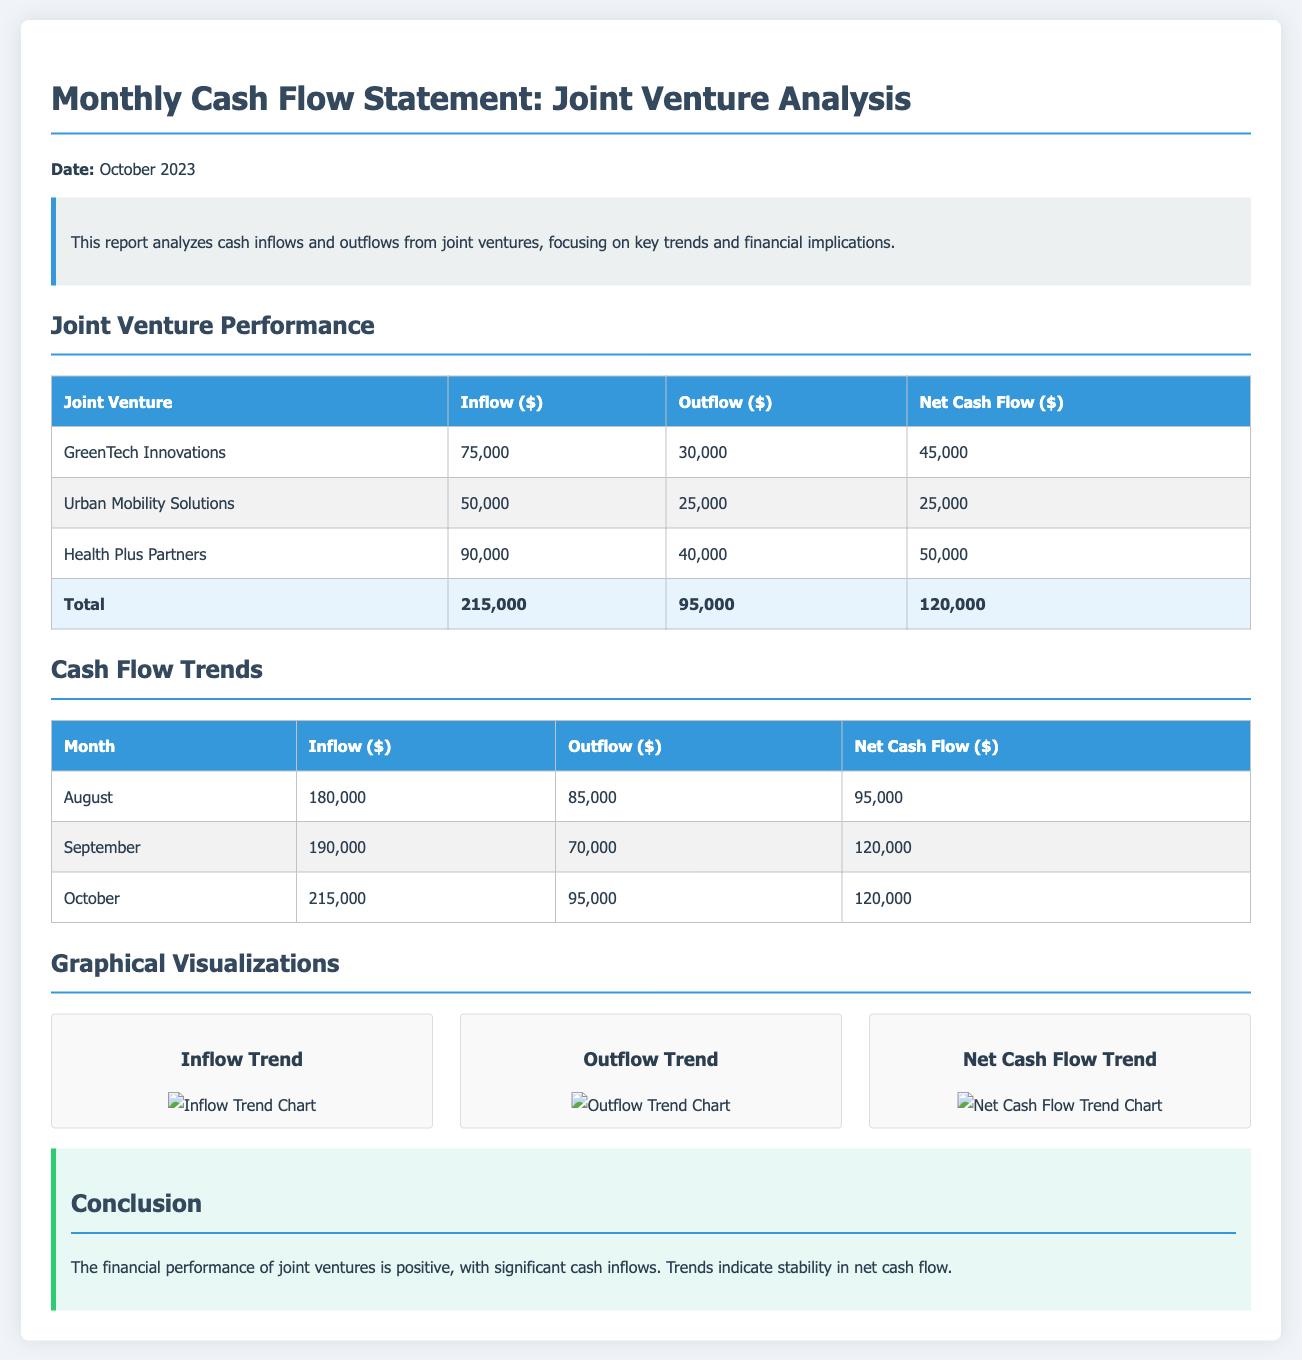What is the date of the report? The date of the report is specified at the top of the document as October 2023.
Answer: October 2023 What is the net cash flow of Health Plus Partners? The net cash flow for Health Plus Partners, found in the joint venture performance table, is calculated as inflow minus outflow, which is $90,000 - $40,000.
Answer: $50,000 Which joint venture had the highest inflow? The overall inflow data shows that Health Plus Partners has the highest inflow of $90,000 among all joint ventures.
Answer: Health Plus Partners What was the total cash inflow for October? Total inflow for October is the sum of inflows from joint ventures for that month, which is $215,000.
Answer: $215,000 Which month had the lowest outflow? Reviewing the cash flow trends, September shows the lowest outflow of $70,000.
Answer: September What is the trend for net cash flow over the three months? The net cash flow trend indicates that it has a steady pattern increasing from $95,000 in August to $120,000 in both September and October.
Answer: Increasing What is the total cash outflow from all joint ventures? The total cash outflow is calculated as the sum of all outflows listed in the joint venture performance table, which amounts to $95,000.
Answer: $95,000 How many joint ventures are listed in the performance table? The performance table contains data on three joint ventures, indicated in the table.
Answer: Three What is the highest net cash flow listed among these joint ventures? The highest net cash flow is indicated in the table as $50,000 from Health Plus Partners.
Answer: $50,000 